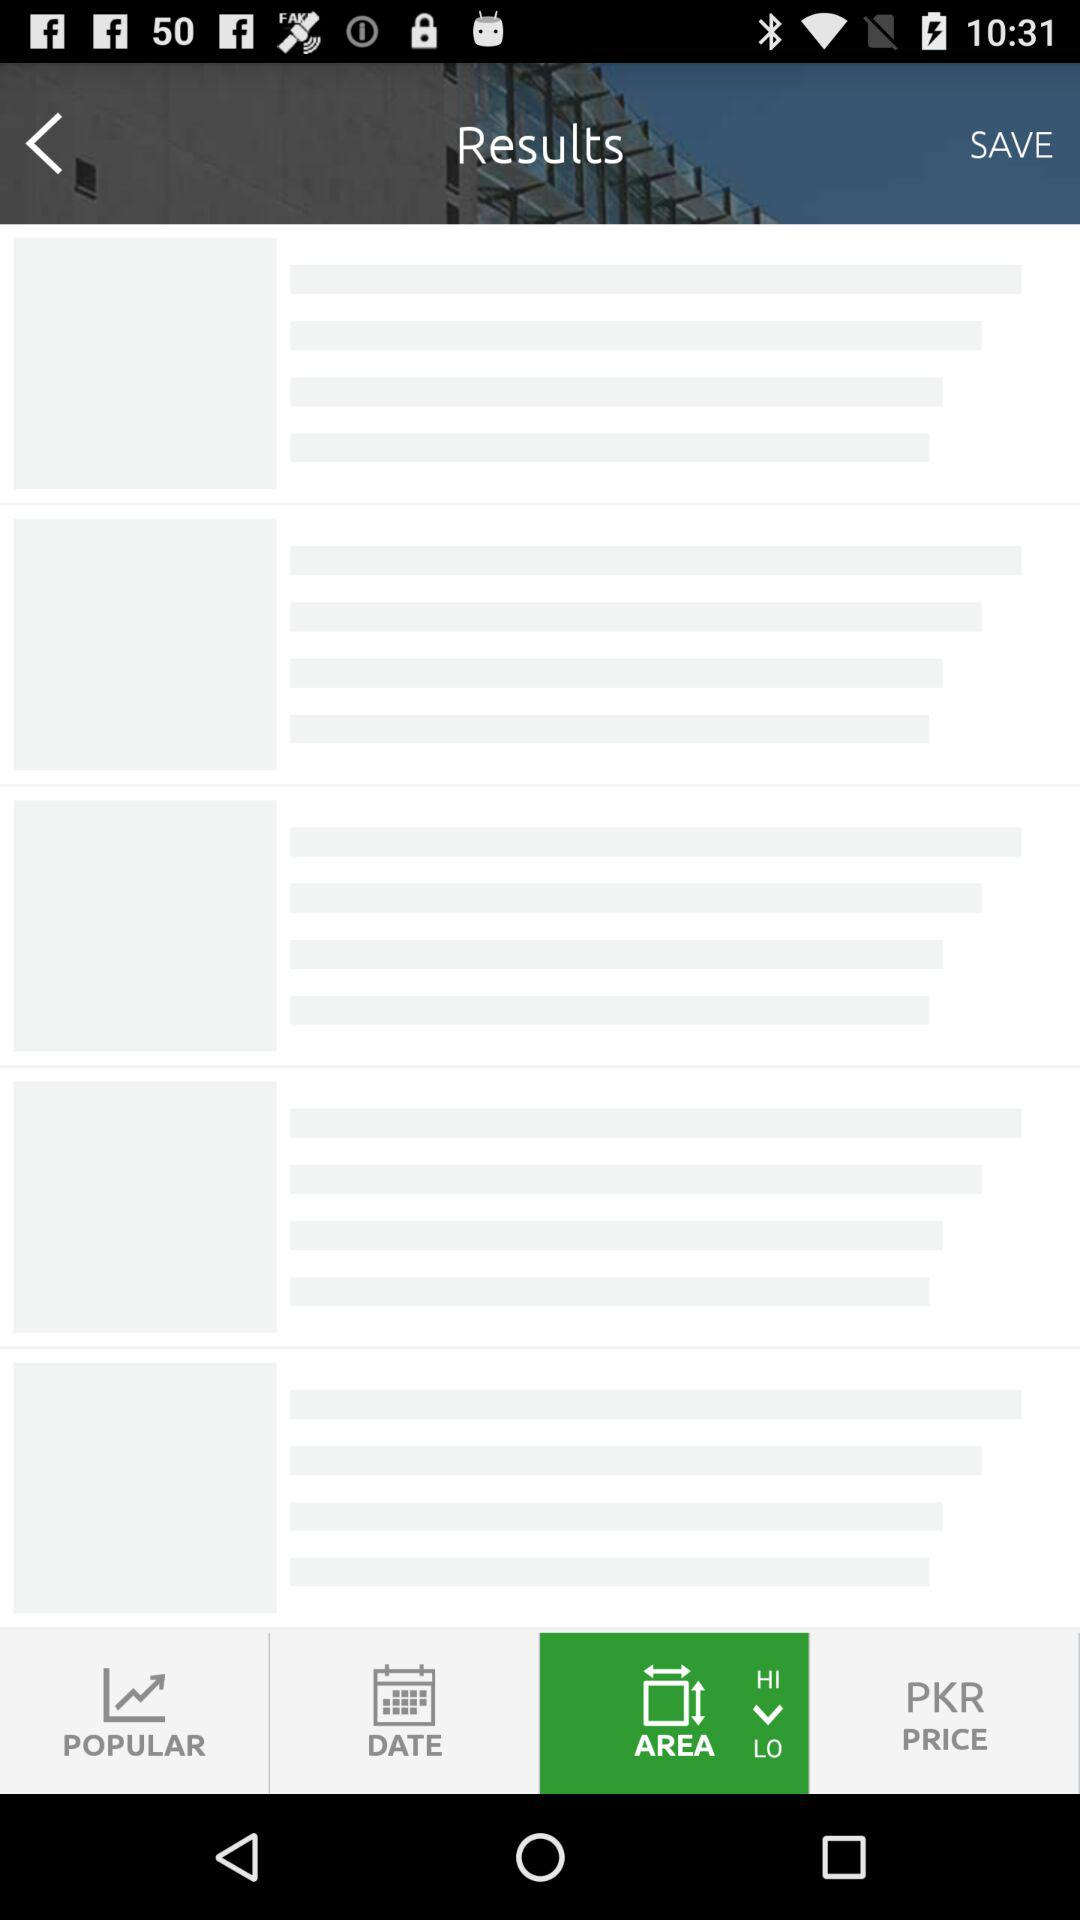What is the application name? The application name is "zameen.com". 